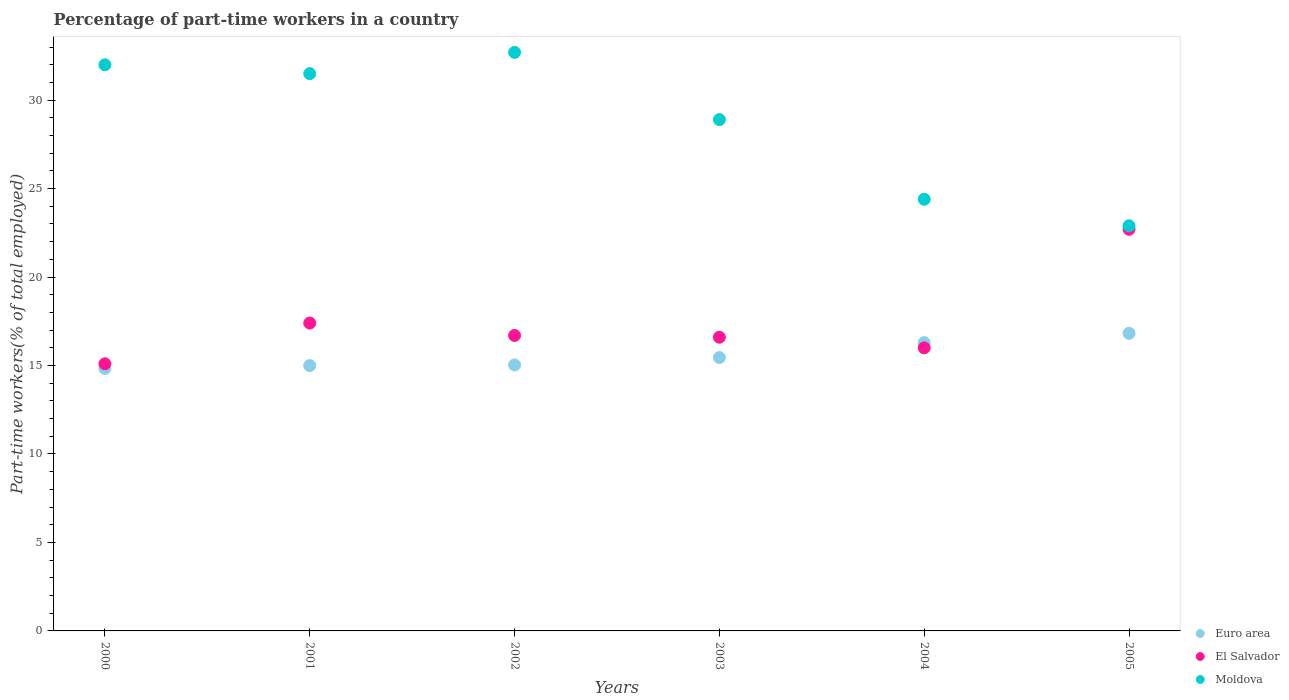What is the percentage of part-time workers in Euro area in 2002?
Give a very brief answer. 15.03. Across all years, what is the maximum percentage of part-time workers in Euro area?
Your answer should be compact. 16.82. Across all years, what is the minimum percentage of part-time workers in El Salvador?
Your answer should be compact. 15.1. In which year was the percentage of part-time workers in El Salvador maximum?
Keep it short and to the point. 2005. What is the total percentage of part-time workers in El Salvador in the graph?
Give a very brief answer. 104.5. What is the difference between the percentage of part-time workers in El Salvador in 2001 and that in 2002?
Keep it short and to the point. 0.7. What is the difference between the percentage of part-time workers in Moldova in 2003 and the percentage of part-time workers in Euro area in 2005?
Give a very brief answer. 12.08. What is the average percentage of part-time workers in Euro area per year?
Offer a very short reply. 15.57. In the year 2002, what is the difference between the percentage of part-time workers in El Salvador and percentage of part-time workers in Euro area?
Offer a terse response. 1.67. What is the ratio of the percentage of part-time workers in Moldova in 2001 to that in 2004?
Provide a succinct answer. 1.29. Is the percentage of part-time workers in Euro area in 2003 less than that in 2004?
Offer a terse response. Yes. Is the difference between the percentage of part-time workers in El Salvador in 2003 and 2005 greater than the difference between the percentage of part-time workers in Euro area in 2003 and 2005?
Offer a terse response. No. What is the difference between the highest and the second highest percentage of part-time workers in Euro area?
Keep it short and to the point. 0.52. What is the difference between the highest and the lowest percentage of part-time workers in El Salvador?
Provide a succinct answer. 7.6. Is it the case that in every year, the sum of the percentage of part-time workers in El Salvador and percentage of part-time workers in Euro area  is greater than the percentage of part-time workers in Moldova?
Keep it short and to the point. No. Is the percentage of part-time workers in El Salvador strictly greater than the percentage of part-time workers in Euro area over the years?
Your response must be concise. No. Is the percentage of part-time workers in Euro area strictly less than the percentage of part-time workers in El Salvador over the years?
Provide a short and direct response. No. How many dotlines are there?
Give a very brief answer. 3. Does the graph contain any zero values?
Your response must be concise. No. Does the graph contain grids?
Your answer should be very brief. No. How many legend labels are there?
Offer a very short reply. 3. How are the legend labels stacked?
Your answer should be very brief. Vertical. What is the title of the graph?
Keep it short and to the point. Percentage of part-time workers in a country. Does "Greece" appear as one of the legend labels in the graph?
Offer a very short reply. No. What is the label or title of the X-axis?
Offer a very short reply. Years. What is the label or title of the Y-axis?
Offer a terse response. Part-time workers(% of total employed). What is the Part-time workers(% of total employed) of Euro area in 2000?
Your answer should be compact. 14.84. What is the Part-time workers(% of total employed) of El Salvador in 2000?
Keep it short and to the point. 15.1. What is the Part-time workers(% of total employed) of Euro area in 2001?
Make the answer very short. 15. What is the Part-time workers(% of total employed) in El Salvador in 2001?
Give a very brief answer. 17.4. What is the Part-time workers(% of total employed) of Moldova in 2001?
Offer a very short reply. 31.5. What is the Part-time workers(% of total employed) in Euro area in 2002?
Provide a succinct answer. 15.03. What is the Part-time workers(% of total employed) in El Salvador in 2002?
Provide a short and direct response. 16.7. What is the Part-time workers(% of total employed) in Moldova in 2002?
Your response must be concise. 32.7. What is the Part-time workers(% of total employed) of Euro area in 2003?
Ensure brevity in your answer.  15.45. What is the Part-time workers(% of total employed) of El Salvador in 2003?
Provide a short and direct response. 16.6. What is the Part-time workers(% of total employed) in Moldova in 2003?
Ensure brevity in your answer.  28.9. What is the Part-time workers(% of total employed) of Euro area in 2004?
Your response must be concise. 16.3. What is the Part-time workers(% of total employed) of El Salvador in 2004?
Keep it short and to the point. 16. What is the Part-time workers(% of total employed) in Moldova in 2004?
Ensure brevity in your answer.  24.4. What is the Part-time workers(% of total employed) of Euro area in 2005?
Your response must be concise. 16.82. What is the Part-time workers(% of total employed) of El Salvador in 2005?
Your answer should be compact. 22.7. What is the Part-time workers(% of total employed) of Moldova in 2005?
Give a very brief answer. 22.9. Across all years, what is the maximum Part-time workers(% of total employed) in Euro area?
Keep it short and to the point. 16.82. Across all years, what is the maximum Part-time workers(% of total employed) of El Salvador?
Provide a short and direct response. 22.7. Across all years, what is the maximum Part-time workers(% of total employed) in Moldova?
Make the answer very short. 32.7. Across all years, what is the minimum Part-time workers(% of total employed) of Euro area?
Offer a very short reply. 14.84. Across all years, what is the minimum Part-time workers(% of total employed) of El Salvador?
Offer a terse response. 15.1. Across all years, what is the minimum Part-time workers(% of total employed) in Moldova?
Ensure brevity in your answer.  22.9. What is the total Part-time workers(% of total employed) in Euro area in the graph?
Provide a succinct answer. 93.43. What is the total Part-time workers(% of total employed) in El Salvador in the graph?
Your response must be concise. 104.5. What is the total Part-time workers(% of total employed) in Moldova in the graph?
Give a very brief answer. 172.4. What is the difference between the Part-time workers(% of total employed) in Euro area in 2000 and that in 2001?
Give a very brief answer. -0.16. What is the difference between the Part-time workers(% of total employed) of El Salvador in 2000 and that in 2001?
Make the answer very short. -2.3. What is the difference between the Part-time workers(% of total employed) of Euro area in 2000 and that in 2002?
Your answer should be very brief. -0.2. What is the difference between the Part-time workers(% of total employed) of Moldova in 2000 and that in 2002?
Make the answer very short. -0.7. What is the difference between the Part-time workers(% of total employed) in Euro area in 2000 and that in 2003?
Offer a very short reply. -0.61. What is the difference between the Part-time workers(% of total employed) of El Salvador in 2000 and that in 2003?
Ensure brevity in your answer.  -1.5. What is the difference between the Part-time workers(% of total employed) in Moldova in 2000 and that in 2003?
Keep it short and to the point. 3.1. What is the difference between the Part-time workers(% of total employed) of Euro area in 2000 and that in 2004?
Your answer should be very brief. -1.46. What is the difference between the Part-time workers(% of total employed) in Euro area in 2000 and that in 2005?
Your response must be concise. -1.98. What is the difference between the Part-time workers(% of total employed) of El Salvador in 2000 and that in 2005?
Provide a succinct answer. -7.6. What is the difference between the Part-time workers(% of total employed) of Moldova in 2000 and that in 2005?
Your answer should be compact. 9.1. What is the difference between the Part-time workers(% of total employed) of Euro area in 2001 and that in 2002?
Provide a succinct answer. -0.04. What is the difference between the Part-time workers(% of total employed) in Euro area in 2001 and that in 2003?
Offer a very short reply. -0.46. What is the difference between the Part-time workers(% of total employed) in Euro area in 2001 and that in 2004?
Your answer should be compact. -1.3. What is the difference between the Part-time workers(% of total employed) in Euro area in 2001 and that in 2005?
Your answer should be very brief. -1.83. What is the difference between the Part-time workers(% of total employed) of Moldova in 2001 and that in 2005?
Keep it short and to the point. 8.6. What is the difference between the Part-time workers(% of total employed) in Euro area in 2002 and that in 2003?
Your response must be concise. -0.42. What is the difference between the Part-time workers(% of total employed) in Euro area in 2002 and that in 2004?
Offer a terse response. -1.26. What is the difference between the Part-time workers(% of total employed) of Moldova in 2002 and that in 2004?
Give a very brief answer. 8.3. What is the difference between the Part-time workers(% of total employed) in Euro area in 2002 and that in 2005?
Provide a short and direct response. -1.79. What is the difference between the Part-time workers(% of total employed) of El Salvador in 2002 and that in 2005?
Offer a terse response. -6. What is the difference between the Part-time workers(% of total employed) in Moldova in 2002 and that in 2005?
Offer a terse response. 9.8. What is the difference between the Part-time workers(% of total employed) of Euro area in 2003 and that in 2004?
Your answer should be compact. -0.85. What is the difference between the Part-time workers(% of total employed) of El Salvador in 2003 and that in 2004?
Your answer should be very brief. 0.6. What is the difference between the Part-time workers(% of total employed) of Moldova in 2003 and that in 2004?
Keep it short and to the point. 4.5. What is the difference between the Part-time workers(% of total employed) in Euro area in 2003 and that in 2005?
Your answer should be very brief. -1.37. What is the difference between the Part-time workers(% of total employed) of El Salvador in 2003 and that in 2005?
Your response must be concise. -6.1. What is the difference between the Part-time workers(% of total employed) of Moldova in 2003 and that in 2005?
Provide a short and direct response. 6. What is the difference between the Part-time workers(% of total employed) in Euro area in 2004 and that in 2005?
Offer a very short reply. -0.52. What is the difference between the Part-time workers(% of total employed) of Moldova in 2004 and that in 2005?
Keep it short and to the point. 1.5. What is the difference between the Part-time workers(% of total employed) of Euro area in 2000 and the Part-time workers(% of total employed) of El Salvador in 2001?
Give a very brief answer. -2.56. What is the difference between the Part-time workers(% of total employed) of Euro area in 2000 and the Part-time workers(% of total employed) of Moldova in 2001?
Provide a succinct answer. -16.66. What is the difference between the Part-time workers(% of total employed) in El Salvador in 2000 and the Part-time workers(% of total employed) in Moldova in 2001?
Make the answer very short. -16.4. What is the difference between the Part-time workers(% of total employed) in Euro area in 2000 and the Part-time workers(% of total employed) in El Salvador in 2002?
Give a very brief answer. -1.86. What is the difference between the Part-time workers(% of total employed) of Euro area in 2000 and the Part-time workers(% of total employed) of Moldova in 2002?
Your answer should be very brief. -17.86. What is the difference between the Part-time workers(% of total employed) in El Salvador in 2000 and the Part-time workers(% of total employed) in Moldova in 2002?
Offer a very short reply. -17.6. What is the difference between the Part-time workers(% of total employed) of Euro area in 2000 and the Part-time workers(% of total employed) of El Salvador in 2003?
Give a very brief answer. -1.76. What is the difference between the Part-time workers(% of total employed) in Euro area in 2000 and the Part-time workers(% of total employed) in Moldova in 2003?
Your answer should be compact. -14.06. What is the difference between the Part-time workers(% of total employed) of El Salvador in 2000 and the Part-time workers(% of total employed) of Moldova in 2003?
Offer a terse response. -13.8. What is the difference between the Part-time workers(% of total employed) in Euro area in 2000 and the Part-time workers(% of total employed) in El Salvador in 2004?
Your response must be concise. -1.16. What is the difference between the Part-time workers(% of total employed) of Euro area in 2000 and the Part-time workers(% of total employed) of Moldova in 2004?
Ensure brevity in your answer.  -9.56. What is the difference between the Part-time workers(% of total employed) of El Salvador in 2000 and the Part-time workers(% of total employed) of Moldova in 2004?
Provide a succinct answer. -9.3. What is the difference between the Part-time workers(% of total employed) of Euro area in 2000 and the Part-time workers(% of total employed) of El Salvador in 2005?
Your response must be concise. -7.86. What is the difference between the Part-time workers(% of total employed) of Euro area in 2000 and the Part-time workers(% of total employed) of Moldova in 2005?
Offer a very short reply. -8.06. What is the difference between the Part-time workers(% of total employed) of El Salvador in 2000 and the Part-time workers(% of total employed) of Moldova in 2005?
Offer a terse response. -7.8. What is the difference between the Part-time workers(% of total employed) in Euro area in 2001 and the Part-time workers(% of total employed) in El Salvador in 2002?
Keep it short and to the point. -1.7. What is the difference between the Part-time workers(% of total employed) in Euro area in 2001 and the Part-time workers(% of total employed) in Moldova in 2002?
Your answer should be very brief. -17.7. What is the difference between the Part-time workers(% of total employed) of El Salvador in 2001 and the Part-time workers(% of total employed) of Moldova in 2002?
Your answer should be very brief. -15.3. What is the difference between the Part-time workers(% of total employed) of Euro area in 2001 and the Part-time workers(% of total employed) of El Salvador in 2003?
Ensure brevity in your answer.  -1.6. What is the difference between the Part-time workers(% of total employed) in Euro area in 2001 and the Part-time workers(% of total employed) in Moldova in 2003?
Keep it short and to the point. -13.9. What is the difference between the Part-time workers(% of total employed) in El Salvador in 2001 and the Part-time workers(% of total employed) in Moldova in 2003?
Give a very brief answer. -11.5. What is the difference between the Part-time workers(% of total employed) of Euro area in 2001 and the Part-time workers(% of total employed) of El Salvador in 2004?
Keep it short and to the point. -1. What is the difference between the Part-time workers(% of total employed) of Euro area in 2001 and the Part-time workers(% of total employed) of Moldova in 2004?
Offer a terse response. -9.4. What is the difference between the Part-time workers(% of total employed) in Euro area in 2001 and the Part-time workers(% of total employed) in El Salvador in 2005?
Your response must be concise. -7.7. What is the difference between the Part-time workers(% of total employed) in Euro area in 2001 and the Part-time workers(% of total employed) in Moldova in 2005?
Ensure brevity in your answer.  -7.9. What is the difference between the Part-time workers(% of total employed) of El Salvador in 2001 and the Part-time workers(% of total employed) of Moldova in 2005?
Make the answer very short. -5.5. What is the difference between the Part-time workers(% of total employed) of Euro area in 2002 and the Part-time workers(% of total employed) of El Salvador in 2003?
Your response must be concise. -1.57. What is the difference between the Part-time workers(% of total employed) in Euro area in 2002 and the Part-time workers(% of total employed) in Moldova in 2003?
Make the answer very short. -13.87. What is the difference between the Part-time workers(% of total employed) in Euro area in 2002 and the Part-time workers(% of total employed) in El Salvador in 2004?
Ensure brevity in your answer.  -0.97. What is the difference between the Part-time workers(% of total employed) of Euro area in 2002 and the Part-time workers(% of total employed) of Moldova in 2004?
Give a very brief answer. -9.37. What is the difference between the Part-time workers(% of total employed) of Euro area in 2002 and the Part-time workers(% of total employed) of El Salvador in 2005?
Ensure brevity in your answer.  -7.67. What is the difference between the Part-time workers(% of total employed) in Euro area in 2002 and the Part-time workers(% of total employed) in Moldova in 2005?
Give a very brief answer. -7.87. What is the difference between the Part-time workers(% of total employed) of Euro area in 2003 and the Part-time workers(% of total employed) of El Salvador in 2004?
Your response must be concise. -0.55. What is the difference between the Part-time workers(% of total employed) of Euro area in 2003 and the Part-time workers(% of total employed) of Moldova in 2004?
Ensure brevity in your answer.  -8.95. What is the difference between the Part-time workers(% of total employed) of Euro area in 2003 and the Part-time workers(% of total employed) of El Salvador in 2005?
Give a very brief answer. -7.25. What is the difference between the Part-time workers(% of total employed) in Euro area in 2003 and the Part-time workers(% of total employed) in Moldova in 2005?
Your answer should be compact. -7.45. What is the difference between the Part-time workers(% of total employed) of Euro area in 2004 and the Part-time workers(% of total employed) of El Salvador in 2005?
Offer a terse response. -6.4. What is the difference between the Part-time workers(% of total employed) of Euro area in 2004 and the Part-time workers(% of total employed) of Moldova in 2005?
Your answer should be very brief. -6.6. What is the difference between the Part-time workers(% of total employed) of El Salvador in 2004 and the Part-time workers(% of total employed) of Moldova in 2005?
Ensure brevity in your answer.  -6.9. What is the average Part-time workers(% of total employed) in Euro area per year?
Offer a very short reply. 15.57. What is the average Part-time workers(% of total employed) in El Salvador per year?
Offer a terse response. 17.42. What is the average Part-time workers(% of total employed) of Moldova per year?
Offer a terse response. 28.73. In the year 2000, what is the difference between the Part-time workers(% of total employed) of Euro area and Part-time workers(% of total employed) of El Salvador?
Offer a very short reply. -0.26. In the year 2000, what is the difference between the Part-time workers(% of total employed) of Euro area and Part-time workers(% of total employed) of Moldova?
Provide a short and direct response. -17.16. In the year 2000, what is the difference between the Part-time workers(% of total employed) of El Salvador and Part-time workers(% of total employed) of Moldova?
Give a very brief answer. -16.9. In the year 2001, what is the difference between the Part-time workers(% of total employed) of Euro area and Part-time workers(% of total employed) of El Salvador?
Offer a terse response. -2.4. In the year 2001, what is the difference between the Part-time workers(% of total employed) of Euro area and Part-time workers(% of total employed) of Moldova?
Provide a short and direct response. -16.5. In the year 2001, what is the difference between the Part-time workers(% of total employed) of El Salvador and Part-time workers(% of total employed) of Moldova?
Offer a very short reply. -14.1. In the year 2002, what is the difference between the Part-time workers(% of total employed) in Euro area and Part-time workers(% of total employed) in El Salvador?
Keep it short and to the point. -1.67. In the year 2002, what is the difference between the Part-time workers(% of total employed) of Euro area and Part-time workers(% of total employed) of Moldova?
Your answer should be compact. -17.67. In the year 2003, what is the difference between the Part-time workers(% of total employed) of Euro area and Part-time workers(% of total employed) of El Salvador?
Offer a very short reply. -1.15. In the year 2003, what is the difference between the Part-time workers(% of total employed) of Euro area and Part-time workers(% of total employed) of Moldova?
Provide a short and direct response. -13.45. In the year 2003, what is the difference between the Part-time workers(% of total employed) in El Salvador and Part-time workers(% of total employed) in Moldova?
Keep it short and to the point. -12.3. In the year 2004, what is the difference between the Part-time workers(% of total employed) in Euro area and Part-time workers(% of total employed) in El Salvador?
Your answer should be very brief. 0.3. In the year 2004, what is the difference between the Part-time workers(% of total employed) in Euro area and Part-time workers(% of total employed) in Moldova?
Make the answer very short. -8.1. In the year 2005, what is the difference between the Part-time workers(% of total employed) in Euro area and Part-time workers(% of total employed) in El Salvador?
Ensure brevity in your answer.  -5.88. In the year 2005, what is the difference between the Part-time workers(% of total employed) of Euro area and Part-time workers(% of total employed) of Moldova?
Ensure brevity in your answer.  -6.08. In the year 2005, what is the difference between the Part-time workers(% of total employed) of El Salvador and Part-time workers(% of total employed) of Moldova?
Ensure brevity in your answer.  -0.2. What is the ratio of the Part-time workers(% of total employed) of Euro area in 2000 to that in 2001?
Provide a short and direct response. 0.99. What is the ratio of the Part-time workers(% of total employed) of El Salvador in 2000 to that in 2001?
Your response must be concise. 0.87. What is the ratio of the Part-time workers(% of total employed) in Moldova in 2000 to that in 2001?
Your answer should be very brief. 1.02. What is the ratio of the Part-time workers(% of total employed) in Euro area in 2000 to that in 2002?
Make the answer very short. 0.99. What is the ratio of the Part-time workers(% of total employed) in El Salvador in 2000 to that in 2002?
Ensure brevity in your answer.  0.9. What is the ratio of the Part-time workers(% of total employed) in Moldova in 2000 to that in 2002?
Keep it short and to the point. 0.98. What is the ratio of the Part-time workers(% of total employed) of Euro area in 2000 to that in 2003?
Keep it short and to the point. 0.96. What is the ratio of the Part-time workers(% of total employed) in El Salvador in 2000 to that in 2003?
Offer a very short reply. 0.91. What is the ratio of the Part-time workers(% of total employed) of Moldova in 2000 to that in 2003?
Give a very brief answer. 1.11. What is the ratio of the Part-time workers(% of total employed) of Euro area in 2000 to that in 2004?
Your answer should be compact. 0.91. What is the ratio of the Part-time workers(% of total employed) of El Salvador in 2000 to that in 2004?
Keep it short and to the point. 0.94. What is the ratio of the Part-time workers(% of total employed) in Moldova in 2000 to that in 2004?
Offer a very short reply. 1.31. What is the ratio of the Part-time workers(% of total employed) in Euro area in 2000 to that in 2005?
Ensure brevity in your answer.  0.88. What is the ratio of the Part-time workers(% of total employed) of El Salvador in 2000 to that in 2005?
Your answer should be compact. 0.67. What is the ratio of the Part-time workers(% of total employed) in Moldova in 2000 to that in 2005?
Offer a terse response. 1.4. What is the ratio of the Part-time workers(% of total employed) in El Salvador in 2001 to that in 2002?
Offer a very short reply. 1.04. What is the ratio of the Part-time workers(% of total employed) in Moldova in 2001 to that in 2002?
Offer a terse response. 0.96. What is the ratio of the Part-time workers(% of total employed) in Euro area in 2001 to that in 2003?
Provide a short and direct response. 0.97. What is the ratio of the Part-time workers(% of total employed) in El Salvador in 2001 to that in 2003?
Provide a succinct answer. 1.05. What is the ratio of the Part-time workers(% of total employed) of Moldova in 2001 to that in 2003?
Make the answer very short. 1.09. What is the ratio of the Part-time workers(% of total employed) of Euro area in 2001 to that in 2004?
Keep it short and to the point. 0.92. What is the ratio of the Part-time workers(% of total employed) of El Salvador in 2001 to that in 2004?
Your response must be concise. 1.09. What is the ratio of the Part-time workers(% of total employed) of Moldova in 2001 to that in 2004?
Your response must be concise. 1.29. What is the ratio of the Part-time workers(% of total employed) of Euro area in 2001 to that in 2005?
Provide a short and direct response. 0.89. What is the ratio of the Part-time workers(% of total employed) in El Salvador in 2001 to that in 2005?
Provide a short and direct response. 0.77. What is the ratio of the Part-time workers(% of total employed) in Moldova in 2001 to that in 2005?
Offer a terse response. 1.38. What is the ratio of the Part-time workers(% of total employed) of Moldova in 2002 to that in 2003?
Your response must be concise. 1.13. What is the ratio of the Part-time workers(% of total employed) of Euro area in 2002 to that in 2004?
Offer a terse response. 0.92. What is the ratio of the Part-time workers(% of total employed) in El Salvador in 2002 to that in 2004?
Offer a very short reply. 1.04. What is the ratio of the Part-time workers(% of total employed) in Moldova in 2002 to that in 2004?
Keep it short and to the point. 1.34. What is the ratio of the Part-time workers(% of total employed) of Euro area in 2002 to that in 2005?
Your answer should be very brief. 0.89. What is the ratio of the Part-time workers(% of total employed) in El Salvador in 2002 to that in 2005?
Keep it short and to the point. 0.74. What is the ratio of the Part-time workers(% of total employed) of Moldova in 2002 to that in 2005?
Keep it short and to the point. 1.43. What is the ratio of the Part-time workers(% of total employed) of Euro area in 2003 to that in 2004?
Offer a terse response. 0.95. What is the ratio of the Part-time workers(% of total employed) in El Salvador in 2003 to that in 2004?
Your response must be concise. 1.04. What is the ratio of the Part-time workers(% of total employed) in Moldova in 2003 to that in 2004?
Provide a short and direct response. 1.18. What is the ratio of the Part-time workers(% of total employed) in Euro area in 2003 to that in 2005?
Provide a succinct answer. 0.92. What is the ratio of the Part-time workers(% of total employed) in El Salvador in 2003 to that in 2005?
Offer a terse response. 0.73. What is the ratio of the Part-time workers(% of total employed) of Moldova in 2003 to that in 2005?
Provide a short and direct response. 1.26. What is the ratio of the Part-time workers(% of total employed) in Euro area in 2004 to that in 2005?
Make the answer very short. 0.97. What is the ratio of the Part-time workers(% of total employed) of El Salvador in 2004 to that in 2005?
Offer a very short reply. 0.7. What is the ratio of the Part-time workers(% of total employed) in Moldova in 2004 to that in 2005?
Your response must be concise. 1.07. What is the difference between the highest and the second highest Part-time workers(% of total employed) of Euro area?
Offer a very short reply. 0.52. What is the difference between the highest and the second highest Part-time workers(% of total employed) of El Salvador?
Provide a short and direct response. 5.3. What is the difference between the highest and the lowest Part-time workers(% of total employed) of Euro area?
Provide a succinct answer. 1.98. What is the difference between the highest and the lowest Part-time workers(% of total employed) of Moldova?
Ensure brevity in your answer.  9.8. 